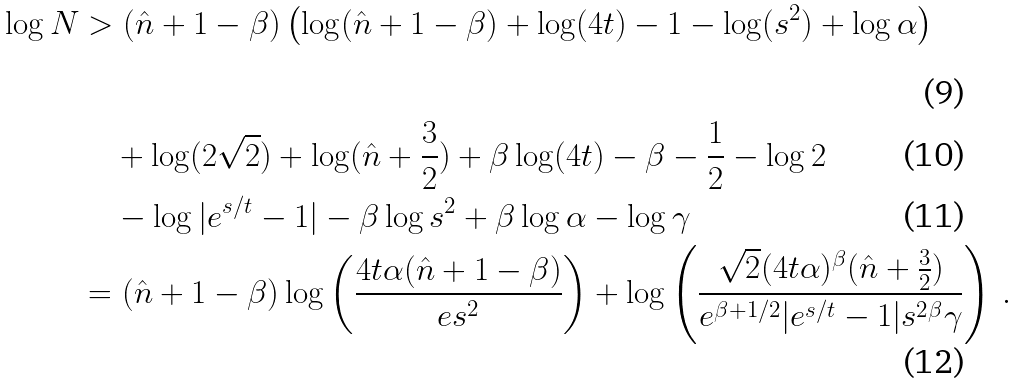<formula> <loc_0><loc_0><loc_500><loc_500>\log N & > ( \hat { n } + 1 - \beta ) \left ( \log ( \hat { n } + 1 - \beta ) + \log ( 4 t ) - 1 - \log ( s ^ { 2 } ) + \log \alpha \right ) \\ & \quad + \log ( 2 \sqrt { 2 } ) + \log ( \hat { n } + \frac { 3 } { 2 } ) + \beta \log ( 4 t ) - \beta - \frac { 1 } { 2 } - \log 2 \\ & \quad - \log | e ^ { s / t } - 1 | - \beta \log { s ^ { 2 } } + \beta \log \alpha - \log \gamma \\ & = ( \hat { n } + 1 - \beta ) \log \left ( \frac { 4 t \alpha ( \hat { n } + 1 - \beta ) } { e s ^ { 2 } } \right ) + \log \left ( \frac { \sqrt { 2 } ( 4 t \alpha ) ^ { \beta } ( \hat { n } + \frac { 3 } { 2 } ) } { e ^ { \beta + 1 / 2 } | e ^ { s / t } - 1 | s ^ { 2 \beta } \gamma } \right ) \, .</formula> 